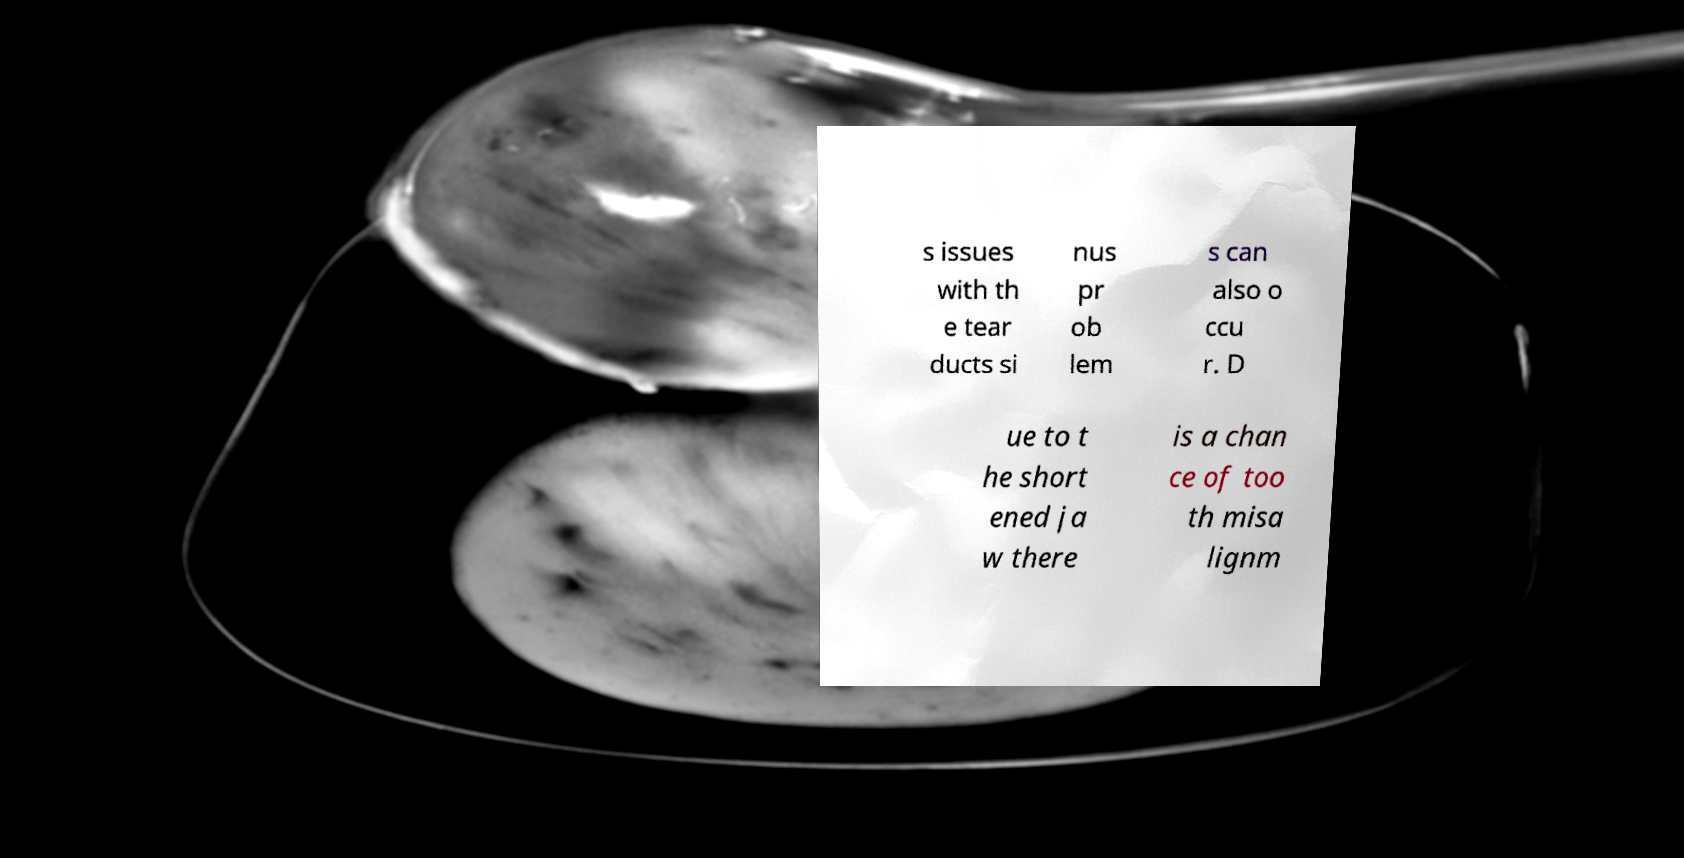Can you accurately transcribe the text from the provided image for me? s issues with th e tear ducts si nus pr ob lem s can also o ccu r. D ue to t he short ened ja w there is a chan ce of too th misa lignm 